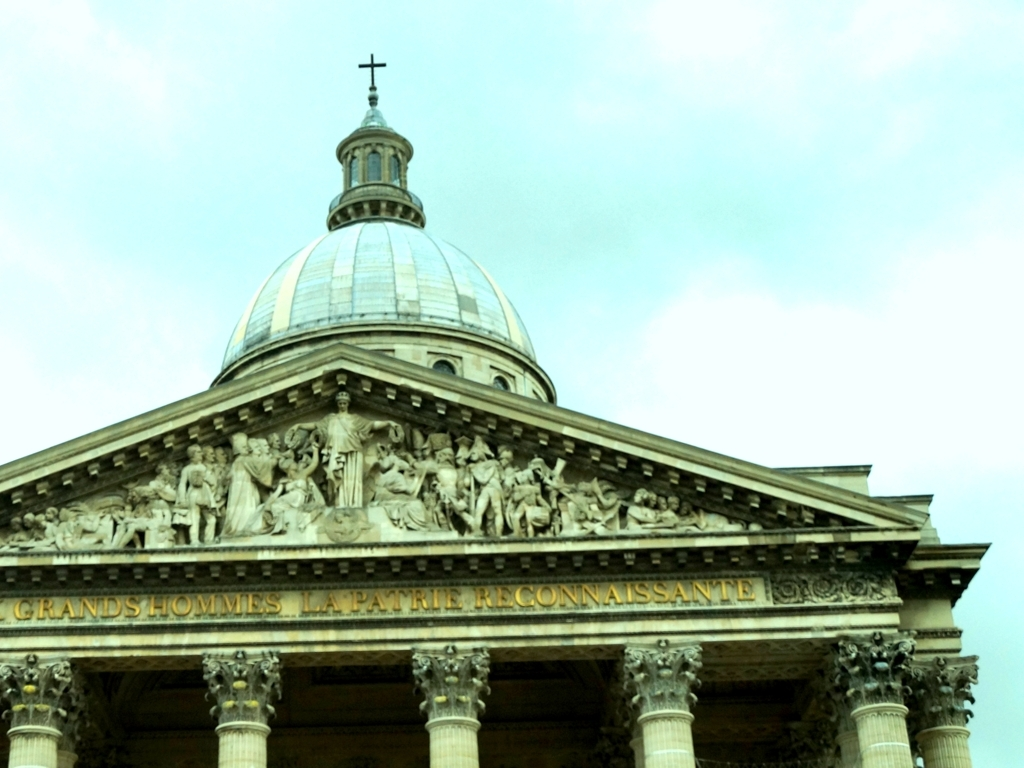What can you tell me about the architectural style of the building depicted in the image? The building features neoclassical architectural elements, such as a prominent dome, Corinthian columns, and a pediment adorned with sculptures, which suggest a style reminiscent of ancient Greek and Roman temples. 